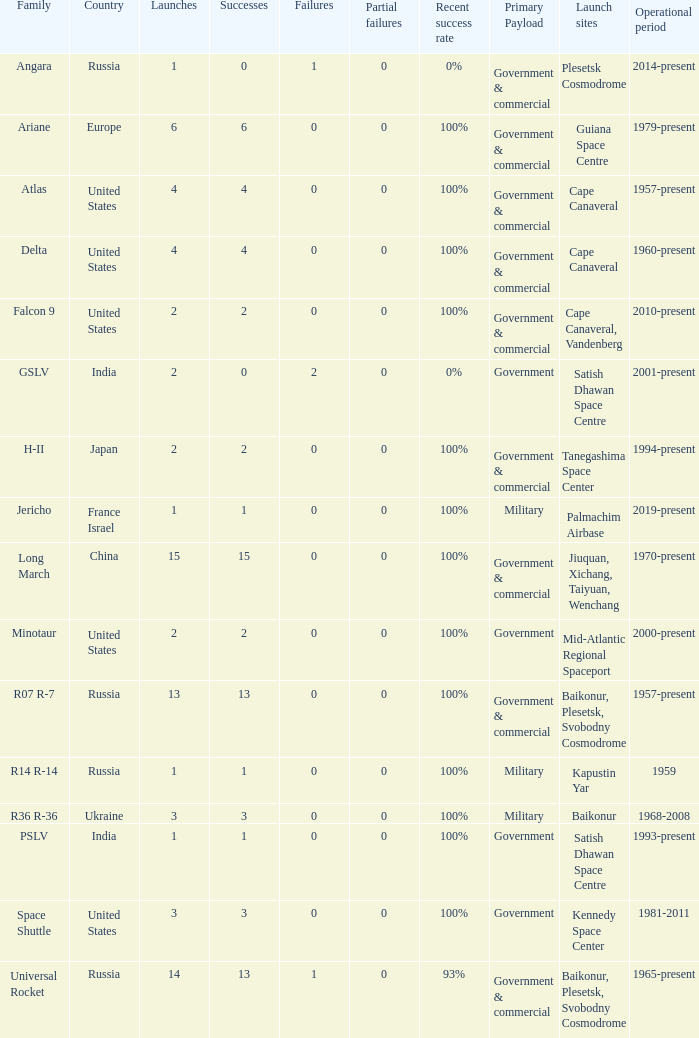What is the number of failure for the country of Russia, and a Family of r14 r-14, and a Partial failures smaller than 0? 0.0. 